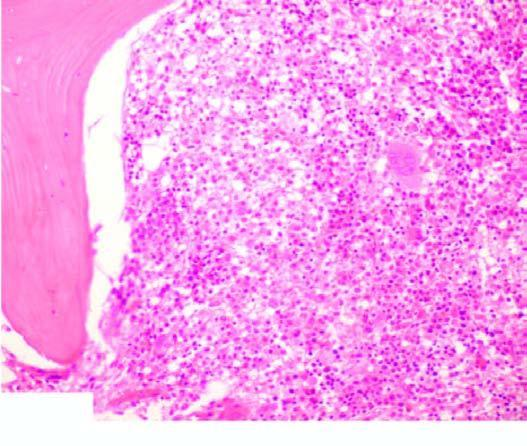how does peripheral blood show presence of a leukaemic cells?
Answer the question using a single word or phrase. With hairy cytoplasmic projections 